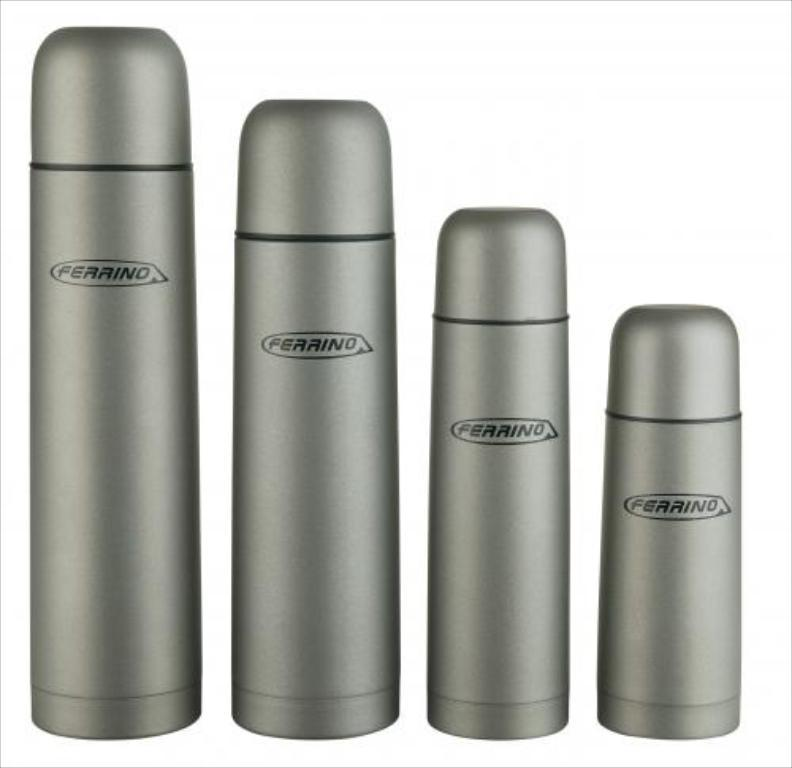<image>
Share a concise interpretation of the image provided. Four gray liquid containers with the logo for Perrino on their center area. 